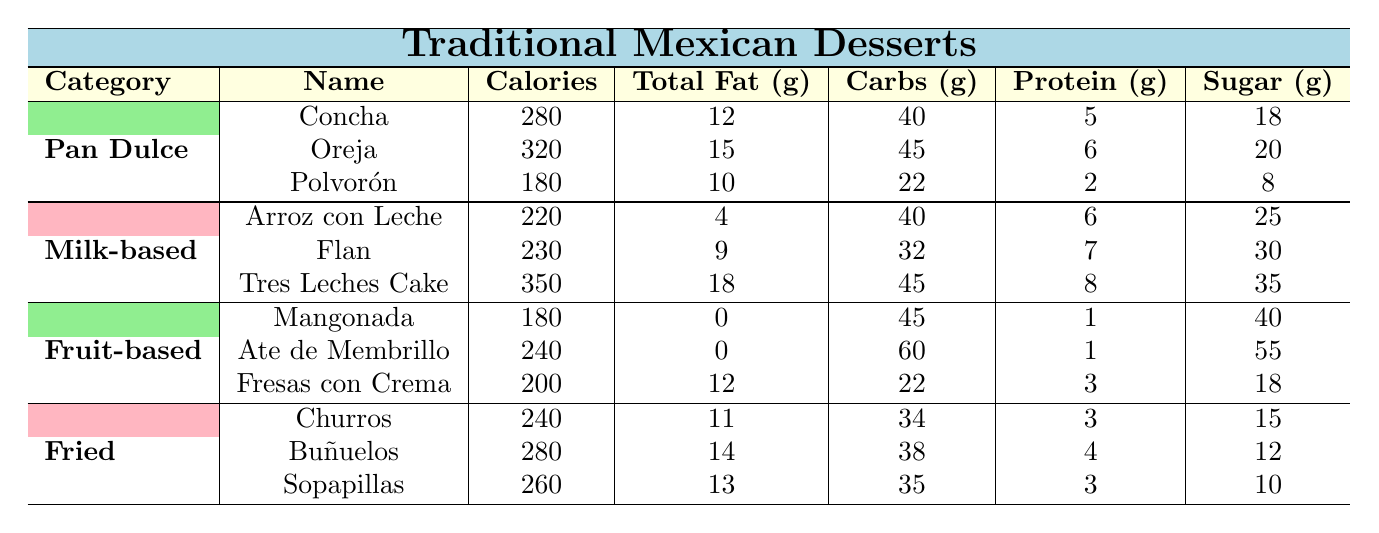What dessert has the highest calorie count? By examining the "Calories" column, we can see that "Tres Leches Cake" has the highest calorie count at 350.
Answer: Tres Leches Cake Which type of dessert has the least total fat? Looking at the "Total Fat (g)" column, "Mangonada" has the least total fat with 0 grams.
Answer: Mangonada What is the total sugar content in both "Arroz con Leche" and "Flan"? Adding the sugar content: Arroz con Leche has 25 grams and Flan has 30 grams. Therefore, the total is 25 + 30 = 55 grams.
Answer: 55 grams Is "Polvorón" lower in calories than "Concha"? Comparing the calories, Polvorón has 180 calories and Concha has 280 calories. Thus, Polvorón is lower in calories.
Answer: Yes What is the average protein content of the "Fried" category desserts? To find the average: Add the protein contents (3 + 4 + 3 = 10) and divide by the number of desserts (10/3 = approximately 3.33).
Answer: Approximately 3.33 grams Which dessert has more sugar, "Ate de Membrillo" or "Fresas con Crema"? "Ate de Membrillo" has 55 grams of sugar, while "Fresas con Crema" has 18 grams. So, Ate de Membrillo has more sugar.
Answer: Ate de Membrillo How many carbohydrates does a "Churro" contain compared to a "Buñuelo"? A Churro contains 34 grams, while a Buñuelo contains 38 grams. Therefore, a Buñuelo has 4 grams more carbohydrates than a Churro.
Answer: 4 grams Which dessert category has the highest average calories? To find this, calculate the average calories for each category. Pan Dulce average = (280 + 320 + 180)/3 = 260; Milk-based average = (220 + 230 + 350)/3 = 266.67; Fruit-based average = (180 + 240 + 200)/3 = 206.67; Fried average = (240 + 280 + 260)/3 = 260. Thus, Milk-based desserts have the highest average at 266.67.
Answer: Milk-based Desserts Does "Oreja" contain more protein than "Polvorón"? Oreja has 6 grams of protein, while Polvorón has only 2 grams. Thus, Oreja contains more protein.
Answer: Yes What is the total calorie count of all the desserts in the "Fruit-based" category? Adding the calories: Mangonada (180) + Ate de Membrillo (240) + Fresas con Crema (200) gives a total of 180 + 240 + 200 = 620 calories.
Answer: 620 calories 